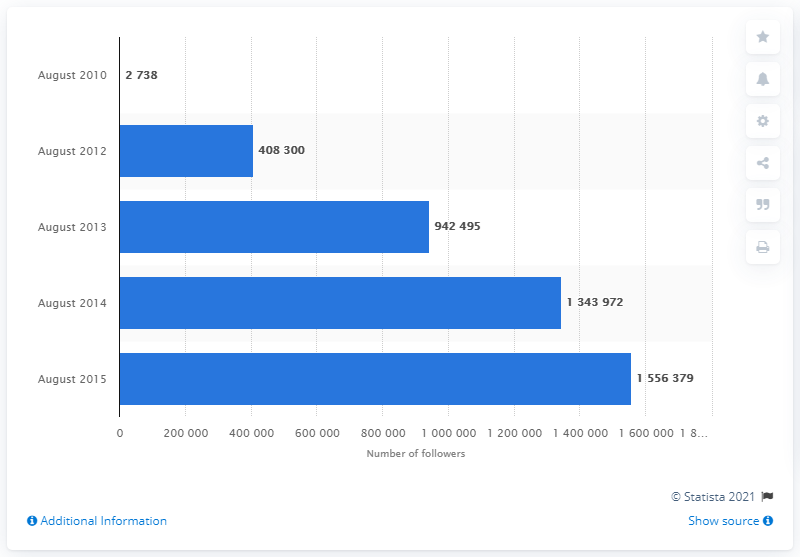Outline some significant characteristics in this image. In 2015, the value was the highest. The value of 2012 is greater than 2010 by 405,562. 